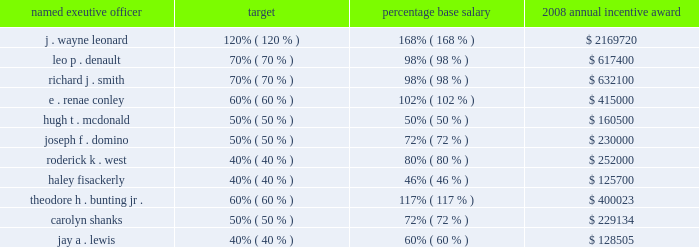After reviewing earnings per share and operating cash flow results against the performance objectives in the above table , the personnel committee set the entergy achievement multiplier at 140% ( 140 % ) of target .
Under the terms of the executive incentive plan , the entergy achievement multiplier is automatically increased by 25 percent for the members of the office of the chief executive ( including mr .
Denault and mr .
Smith , but not the other named executive officers ) , subject to the personnel committee's discretion to adjust the automatic multiplier downward or eliminate it altogether .
In accordance with section 162 ( m ) of the internal revenue code , the multiplier which entergy refers to as the management effectiveness factor is intended to provide the committee , through the exercise of negative discretion , a mechanism to take into consideration the specific achievement factors relating to the overall performance of entergy corporation .
In january 2009 , the committee exercised its negative discretion to eliminate the management effectiveness factor , reflecting the personnel committee's determination that the entergy achievement multiplier , in and of itself without the management effectiveness factor , was consistent with the performance levels achieved by management .
The annual incentive award for the named executive officers ( other than mr .
Leonard , mr .
Denault and mr .
Smith ) is awarded from an incentive pool approved by the committee .
From this pool , each named executive officer's supervisor determines the annual incentive payment based on the entergy achievement multiplier .
The supervisor has the discretion to increase or decrease the multiple used to determine an incentive award based on individual and business unit performance .
The incentive awards are subject to the ultimate approval of entergy's chief executive officer .
The table shows the executive and management incentive plans payments as a percentage of base salary for 2008 : named exeutive officer target percentage base salary 2008 annual incentive award .
While ms .
Shanks and mr .
Lewis are no longer ceo-entergy mississippi and principal financial officer for the subsidiaries , respectively , ms .
Shanks continues to participate in the executive incentive plan , and mr .
Lewis continues to participate in the management incentive plan as they remain employees of entergy since the contemplated enexus separation has not occurred and enexus remains a subsidiary of entergy .
Nuclear retention plan some of entergy's executives , but not any of the named executive officers , participate in a special retention plan for officers and other leaders with special expertise in the nuclear industry .
The committee authorized the plan to attract and retain management talent in the nuclear power field , a field which requires unique technical and other expertise that is in great demand in the utility industry .
The plan provides for bonuses to be paid over a three-year employment period .
Subject to continued employment with a participating company , a participating employee is eligible to receive a special cash bonus consisting of three payments , each consisting of an amount from 15% ( 15 % ) to 30% ( 30 % ) of such participant's base salary. .
What is the difference of annual incentive award between the top two highest paid executives? 
Computations: (2169720 - 632100)
Answer: 1537620.0. 